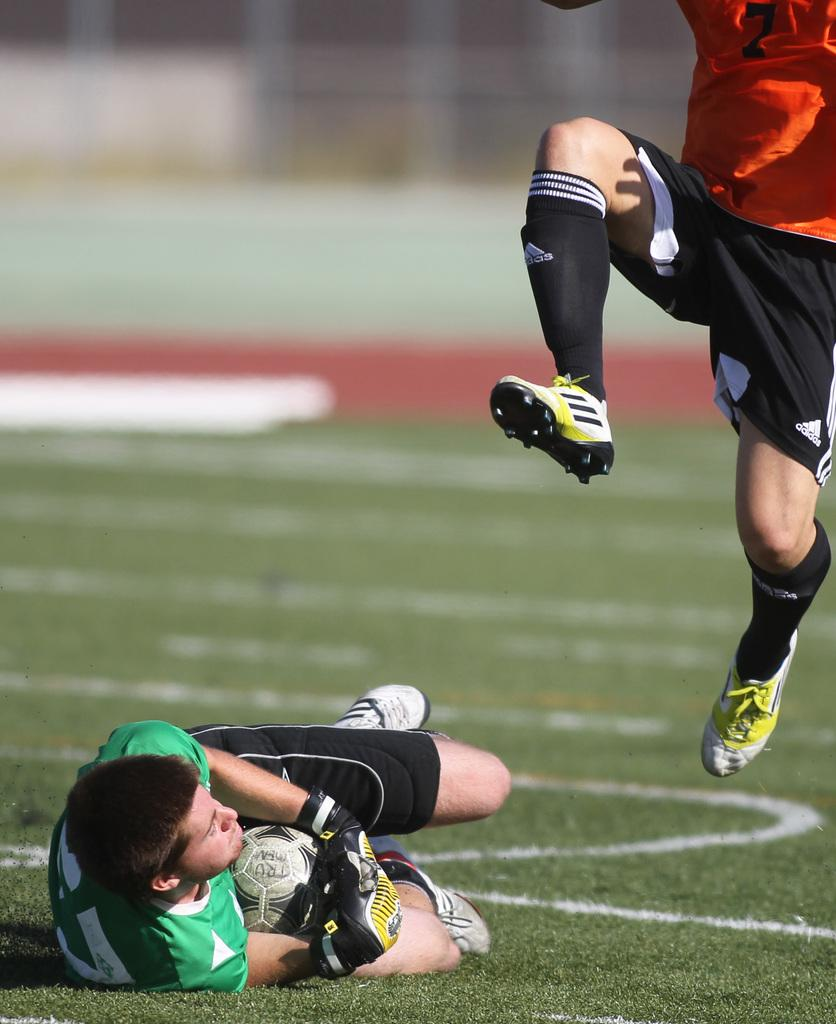What is the man in the image wearing? The man is wearing a green t-shirt. What is the man doing in the image? The man is on the ground and holding a ball in his hand. How many men are in the image? There are two men in the image. What is the second man wearing? The second man is wearing an orange t-shirt. What is the second man doing in the image? The second man is in the air. Are there any children playing with butter in the image? There are no children or butter present in the image. 